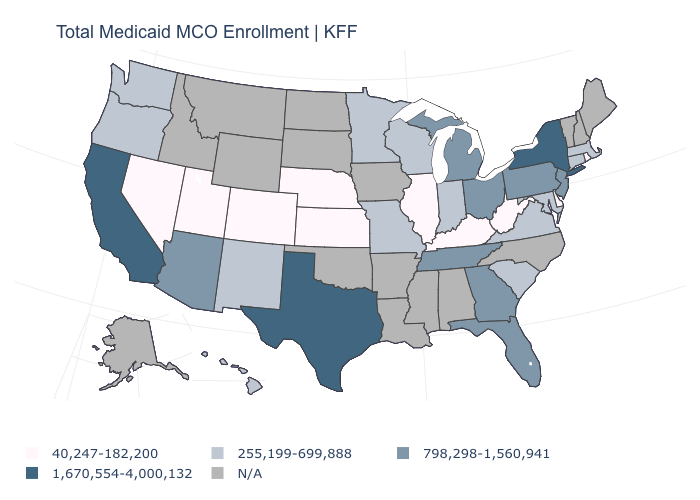Name the states that have a value in the range 255,199-699,888?
Give a very brief answer. Connecticut, Hawaii, Indiana, Maryland, Massachusetts, Minnesota, Missouri, New Mexico, Oregon, South Carolina, Virginia, Washington, Wisconsin. What is the value of Hawaii?
Quick response, please. 255,199-699,888. Does the first symbol in the legend represent the smallest category?
Short answer required. Yes. What is the value of Virginia?
Write a very short answer. 255,199-699,888. Among the states that border Mississippi , which have the lowest value?
Give a very brief answer. Tennessee. Which states have the lowest value in the USA?
Keep it brief. Colorado, Delaware, Illinois, Kansas, Kentucky, Nebraska, Nevada, Rhode Island, Utah, West Virginia. What is the value of New Hampshire?
Concise answer only. N/A. Name the states that have a value in the range 798,298-1,560,941?
Quick response, please. Arizona, Florida, Georgia, Michigan, New Jersey, Ohio, Pennsylvania, Tennessee. What is the value of South Carolina?
Keep it brief. 255,199-699,888. What is the value of Washington?
Keep it brief. 255,199-699,888. Name the states that have a value in the range 40,247-182,200?
Short answer required. Colorado, Delaware, Illinois, Kansas, Kentucky, Nebraska, Nevada, Rhode Island, Utah, West Virginia. What is the lowest value in states that border Illinois?
Be succinct. 40,247-182,200. Which states have the lowest value in the USA?
Be succinct. Colorado, Delaware, Illinois, Kansas, Kentucky, Nebraska, Nevada, Rhode Island, Utah, West Virginia. Name the states that have a value in the range 255,199-699,888?
Keep it brief. Connecticut, Hawaii, Indiana, Maryland, Massachusetts, Minnesota, Missouri, New Mexico, Oregon, South Carolina, Virginia, Washington, Wisconsin. What is the value of Minnesota?
Give a very brief answer. 255,199-699,888. 